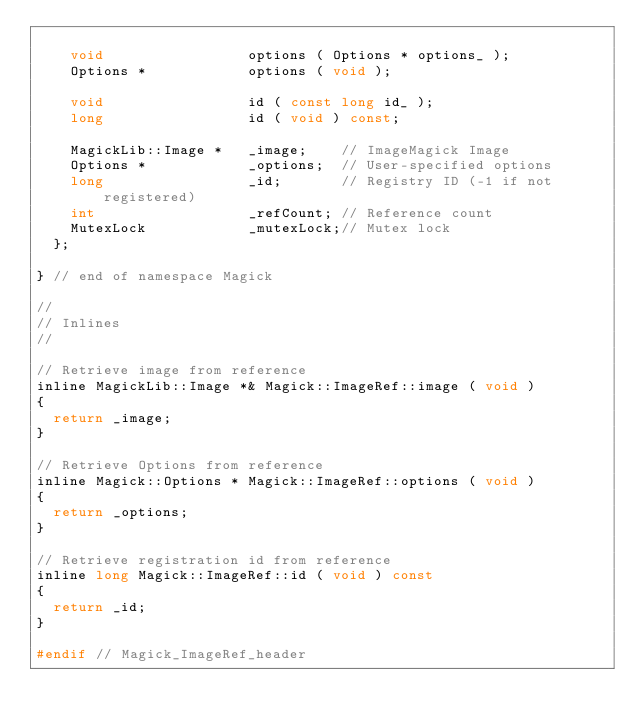Convert code to text. <code><loc_0><loc_0><loc_500><loc_500><_C_>
    void                 options ( Options * options_ );
    Options *            options ( void );

    void                 id ( const long id_ );
    long                 id ( void ) const;

    MagickLib::Image *   _image;    // ImageMagick Image
    Options *            _options;  // User-specified options
    long                 _id;       // Registry ID (-1 if not registered)
    int                  _refCount; // Reference count
    MutexLock            _mutexLock;// Mutex lock
  };

} // end of namespace Magick

//
// Inlines
//

// Retrieve image from reference
inline MagickLib::Image *& Magick::ImageRef::image ( void )
{
  return _image;
}

// Retrieve Options from reference
inline Magick::Options * Magick::ImageRef::options ( void )
{
  return _options;
}

// Retrieve registration id from reference
inline long Magick::ImageRef::id ( void ) const
{
  return _id;
}

#endif // Magick_ImageRef_header
</code> 